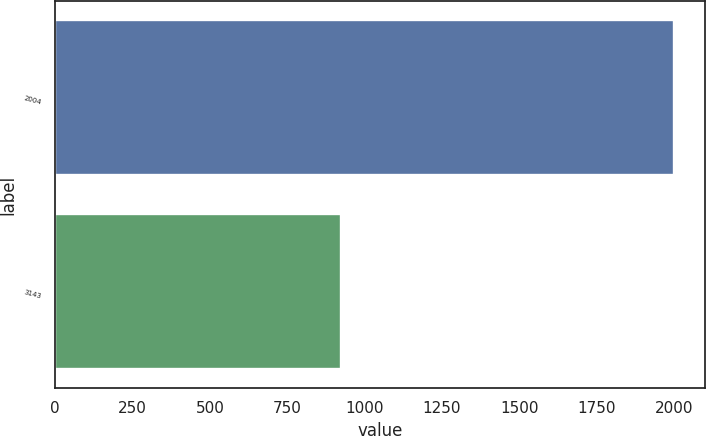Convert chart. <chart><loc_0><loc_0><loc_500><loc_500><bar_chart><fcel>2004<fcel>3143<nl><fcel>2002<fcel>924<nl></chart> 